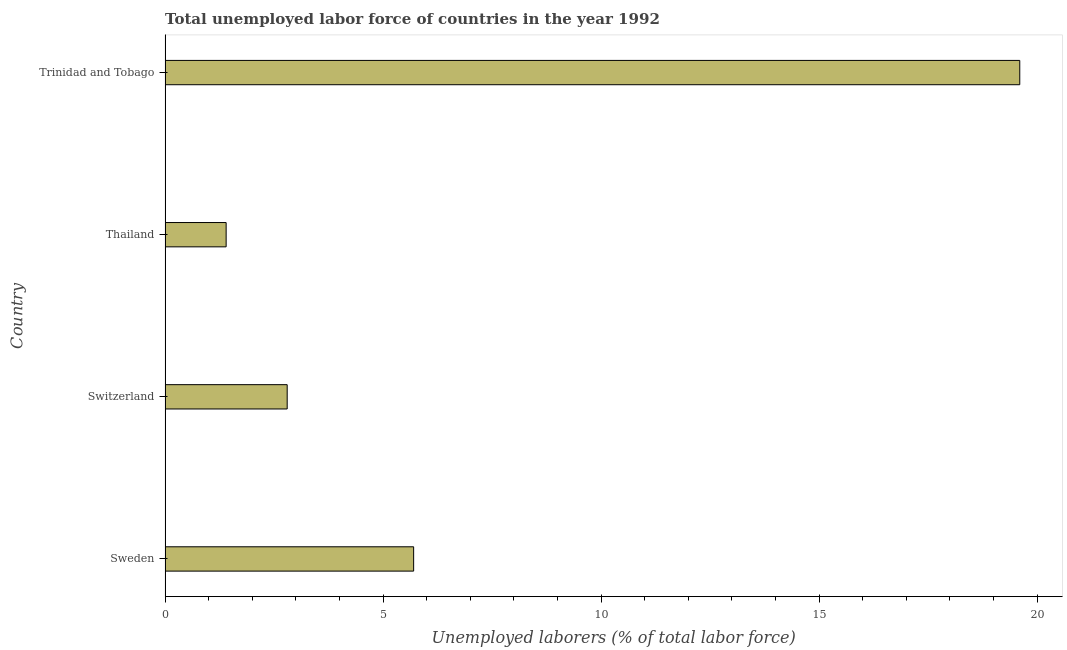Does the graph contain grids?
Provide a short and direct response. No. What is the title of the graph?
Your answer should be compact. Total unemployed labor force of countries in the year 1992. What is the label or title of the X-axis?
Give a very brief answer. Unemployed laborers (% of total labor force). What is the total unemployed labour force in Switzerland?
Ensure brevity in your answer.  2.8. Across all countries, what is the maximum total unemployed labour force?
Keep it short and to the point. 19.6. Across all countries, what is the minimum total unemployed labour force?
Provide a short and direct response. 1.4. In which country was the total unemployed labour force maximum?
Provide a succinct answer. Trinidad and Tobago. In which country was the total unemployed labour force minimum?
Provide a succinct answer. Thailand. What is the sum of the total unemployed labour force?
Ensure brevity in your answer.  29.5. What is the difference between the total unemployed labour force in Sweden and Switzerland?
Keep it short and to the point. 2.9. What is the average total unemployed labour force per country?
Your answer should be very brief. 7.38. What is the median total unemployed labour force?
Offer a very short reply. 4.25. What is the difference between the highest and the second highest total unemployed labour force?
Your answer should be very brief. 13.9. What is the difference between the highest and the lowest total unemployed labour force?
Provide a short and direct response. 18.2. In how many countries, is the total unemployed labour force greater than the average total unemployed labour force taken over all countries?
Offer a terse response. 1. How many bars are there?
Make the answer very short. 4. Are all the bars in the graph horizontal?
Make the answer very short. Yes. How many countries are there in the graph?
Offer a very short reply. 4. Are the values on the major ticks of X-axis written in scientific E-notation?
Your answer should be very brief. No. What is the Unemployed laborers (% of total labor force) of Sweden?
Provide a succinct answer. 5.7. What is the Unemployed laborers (% of total labor force) in Switzerland?
Make the answer very short. 2.8. What is the Unemployed laborers (% of total labor force) in Thailand?
Provide a succinct answer. 1.4. What is the Unemployed laborers (% of total labor force) of Trinidad and Tobago?
Offer a very short reply. 19.6. What is the difference between the Unemployed laborers (% of total labor force) in Sweden and Thailand?
Make the answer very short. 4.3. What is the difference between the Unemployed laborers (% of total labor force) in Sweden and Trinidad and Tobago?
Provide a succinct answer. -13.9. What is the difference between the Unemployed laborers (% of total labor force) in Switzerland and Thailand?
Make the answer very short. 1.4. What is the difference between the Unemployed laborers (% of total labor force) in Switzerland and Trinidad and Tobago?
Your answer should be compact. -16.8. What is the difference between the Unemployed laborers (% of total labor force) in Thailand and Trinidad and Tobago?
Provide a succinct answer. -18.2. What is the ratio of the Unemployed laborers (% of total labor force) in Sweden to that in Switzerland?
Make the answer very short. 2.04. What is the ratio of the Unemployed laborers (% of total labor force) in Sweden to that in Thailand?
Make the answer very short. 4.07. What is the ratio of the Unemployed laborers (% of total labor force) in Sweden to that in Trinidad and Tobago?
Your answer should be compact. 0.29. What is the ratio of the Unemployed laborers (% of total labor force) in Switzerland to that in Trinidad and Tobago?
Your answer should be very brief. 0.14. What is the ratio of the Unemployed laborers (% of total labor force) in Thailand to that in Trinidad and Tobago?
Make the answer very short. 0.07. 